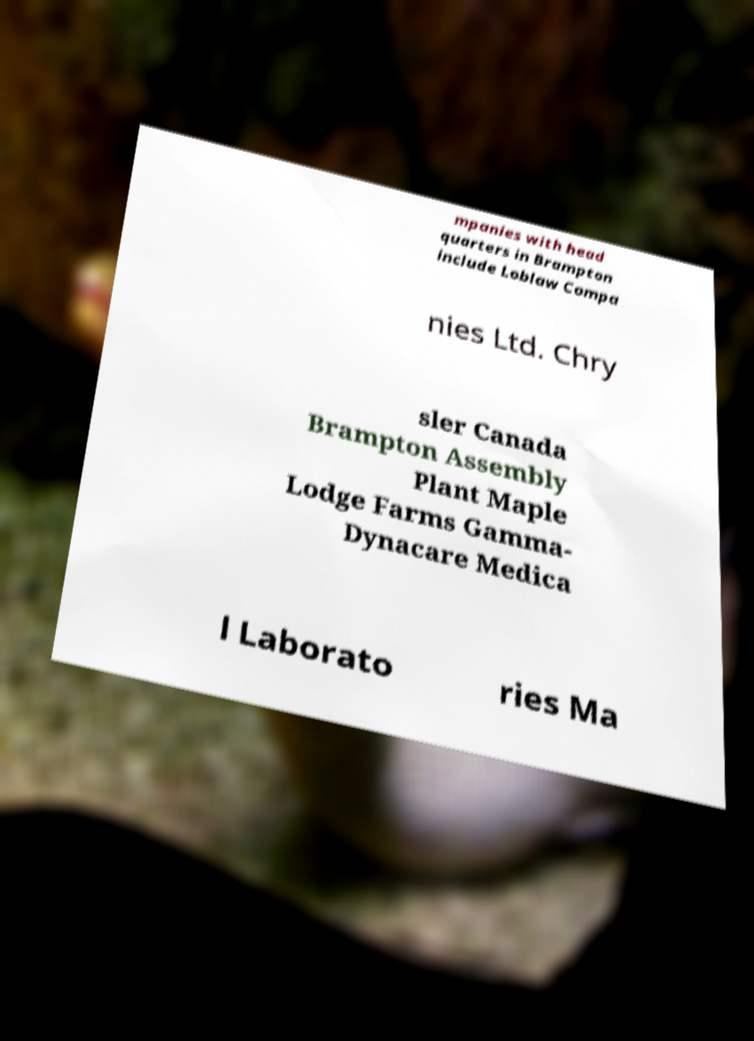What messages or text are displayed in this image? I need them in a readable, typed format. mpanies with head quarters in Brampton include Loblaw Compa nies Ltd. Chry sler Canada Brampton Assembly Plant Maple Lodge Farms Gamma- Dynacare Medica l Laborato ries Ma 